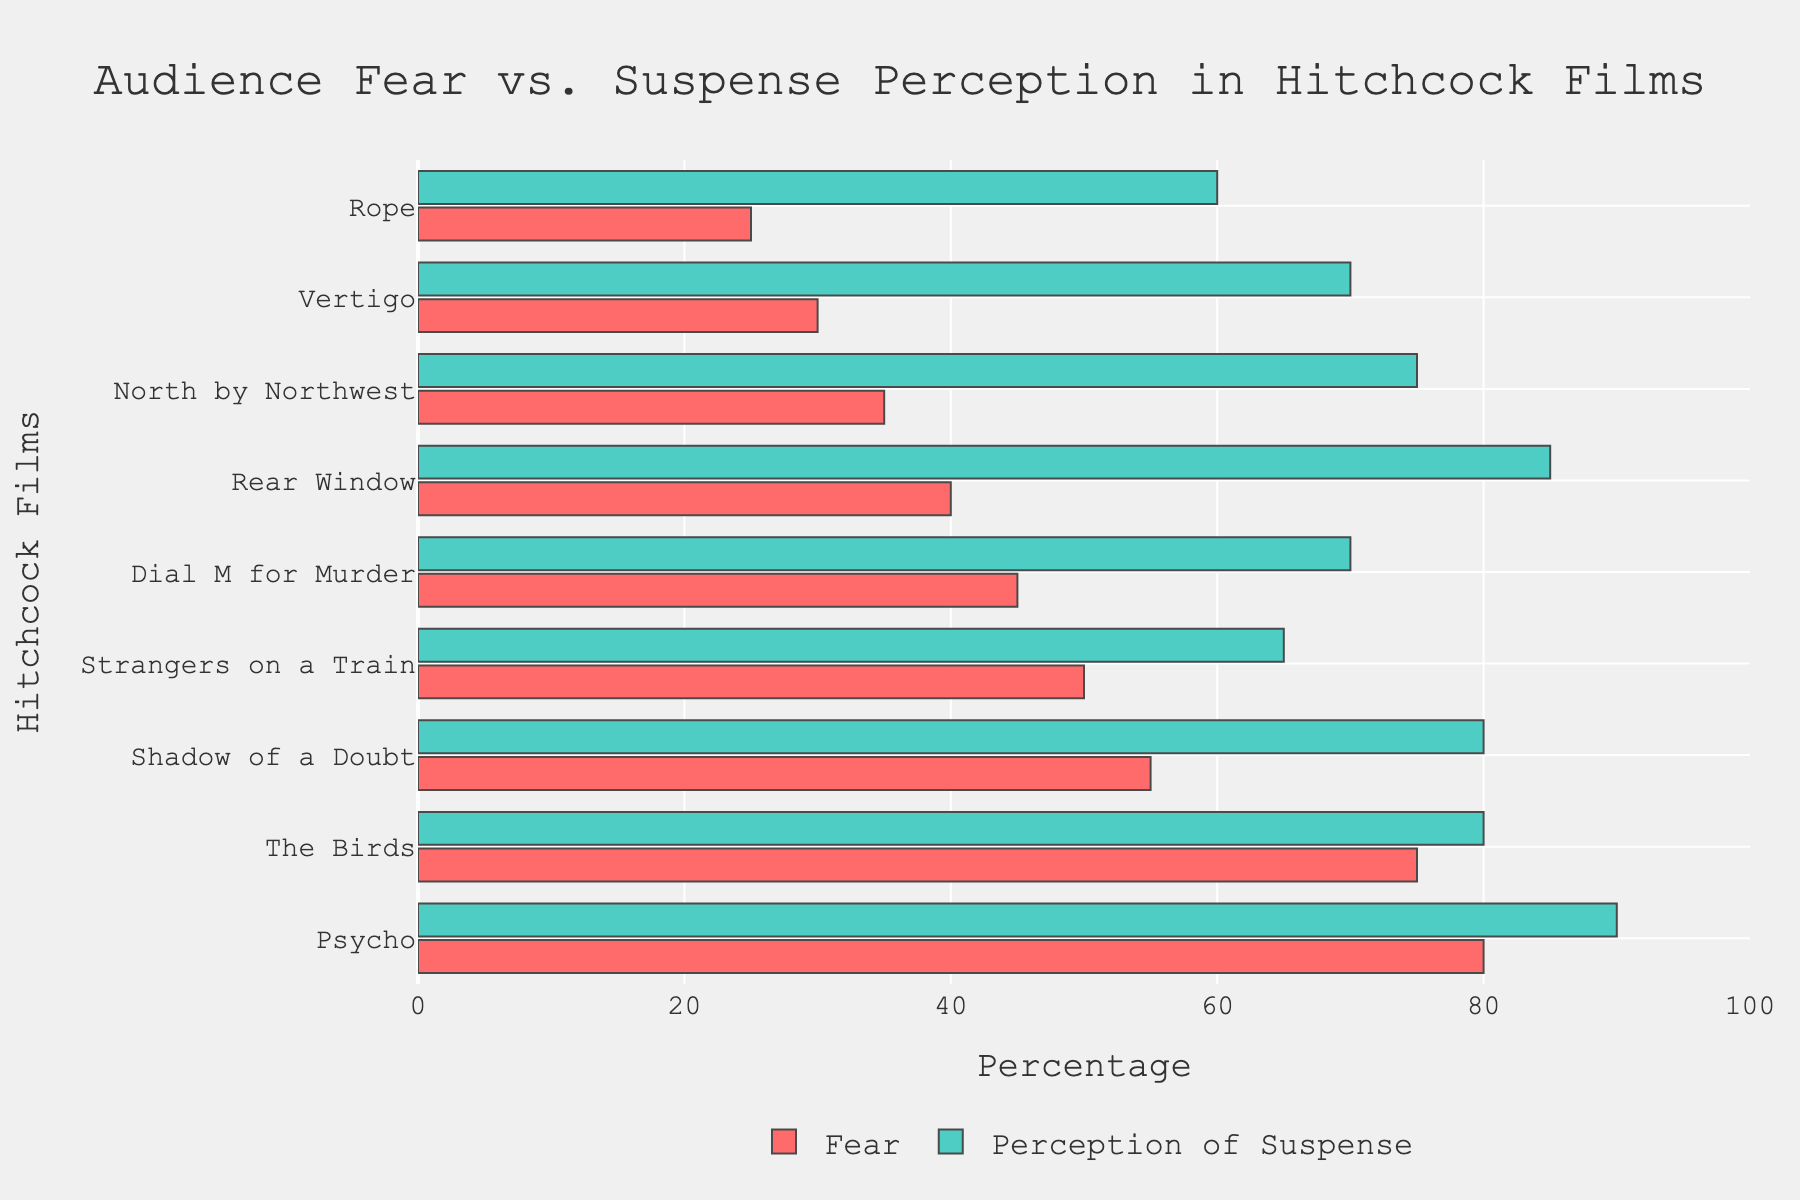Which Hitchcock film has the highest audience fear percentage? The film with the highest audience fear percentage can be found by looking for the longest red bar in the chart.
Answer: Psycho Which film has a higher perception of suspense, "Vertigo" or "Rear Window"? Compare the lengths of the green bars for "Vertigo" and "Rear Window". "Rear Window" has a longer green bar.
Answer: Rear Window What is the difference in audience fear percentage between "Psycho" and "Rope"? The fear percentages for "Psycho" and "Rope" are 80% and 25%, respectively. The difference is 80 - 25 = 55%.
Answer: 55% For which film is the gap between fear and perception of suspense the smallest? Look for the film where the red and green bars are closest in length. "Strangers on a Train" has the smallest gap.
Answer: Strangers on a Train How many films have a perception of suspense percentage of 75% or higher? Count the number of films with green bars that reach or exceed the 75% mark. There are six films: "Vertigo", "Psycho", "Rear Window", "The Birds", "North by Northwest", and "Shadow of a Doubt".
Answer: 6 Which film has the lowest audience fear percentage? The film with the shortest red bar represents the lowest audience fear percentage.
Answer: Rope Is the perception of suspense in "Shadow of a Doubt" higher or lower than that in "Dial M for Murder"? Compare the lengths of the green bars for both films. "Shadow of a Doubt" has a longer green bar indicating a higher perception of suspense.
Answer: Higher Sum the fear percentages of "The Birds" and "Shadow of a Doubt". The fear percentages for "The Birds" and "Shadow of a Doubt" are 75% and 55%, respectively. The sum is 75 + 55 = 130%.
Answer: 130% What is the average audience fear percentage across all the films? Add all the fear percentages (30 + 80 + 40 + 75 + 35 + 50 + 25 + 45 + 55) and divide by the number of films (9). The sum is 435, and the average is 435 / 9 = 48.33%.
Answer: 48.33% In which film is the audience fear perception exactly half of the suspense perception? Identify the film where the length of the red bar is half the length of the green bar. In the chart, "Vertigo" shows 30% fear and 70% suspense, which meets this condition.
Answer: Vertigo 